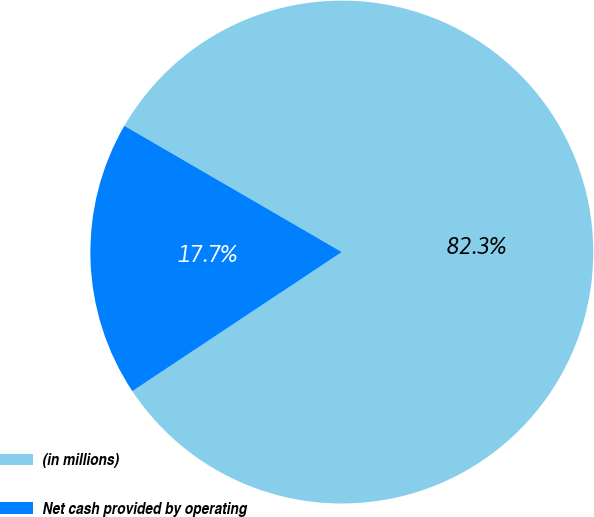Convert chart to OTSL. <chart><loc_0><loc_0><loc_500><loc_500><pie_chart><fcel>(in millions)<fcel>Net cash provided by operating<nl><fcel>82.3%<fcel>17.7%<nl></chart> 